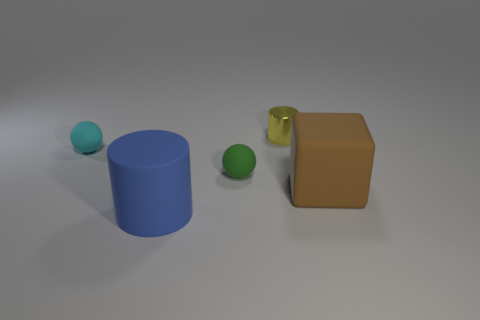There is a large blue object that is the same shape as the tiny yellow shiny object; what is it made of?
Give a very brief answer. Rubber. Are there any metallic things?
Offer a terse response. Yes. What shape is the brown thing that is made of the same material as the cyan sphere?
Make the answer very short. Cube. What is the small yellow thing behind the tiny green object made of?
Ensure brevity in your answer.  Metal. There is a matte ball in front of the tiny object to the left of the large blue thing; what is its size?
Offer a terse response. Small. Is the number of things that are in front of the yellow cylinder greater than the number of tiny cyan shiny cubes?
Offer a terse response. Yes. There is a cylinder that is behind the matte cylinder; is its size the same as the green sphere?
Your answer should be compact. Yes. What is the color of the thing that is right of the green object and on the left side of the large matte block?
Provide a short and direct response. Yellow. There is a green thing that is the same size as the yellow metallic thing; what shape is it?
Offer a terse response. Sphere. Are there an equal number of small cylinders that are in front of the large brown thing and small blue metal things?
Make the answer very short. Yes. 